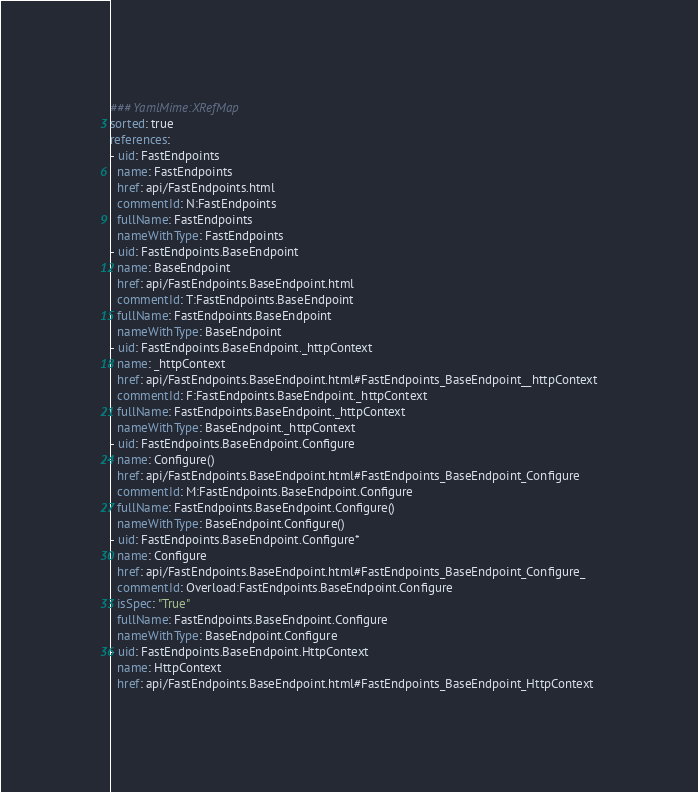<code> <loc_0><loc_0><loc_500><loc_500><_YAML_>### YamlMime:XRefMap
sorted: true
references:
- uid: FastEndpoints
  name: FastEndpoints
  href: api/FastEndpoints.html
  commentId: N:FastEndpoints
  fullName: FastEndpoints
  nameWithType: FastEndpoints
- uid: FastEndpoints.BaseEndpoint
  name: BaseEndpoint
  href: api/FastEndpoints.BaseEndpoint.html
  commentId: T:FastEndpoints.BaseEndpoint
  fullName: FastEndpoints.BaseEndpoint
  nameWithType: BaseEndpoint
- uid: FastEndpoints.BaseEndpoint._httpContext
  name: _httpContext
  href: api/FastEndpoints.BaseEndpoint.html#FastEndpoints_BaseEndpoint__httpContext
  commentId: F:FastEndpoints.BaseEndpoint._httpContext
  fullName: FastEndpoints.BaseEndpoint._httpContext
  nameWithType: BaseEndpoint._httpContext
- uid: FastEndpoints.BaseEndpoint.Configure
  name: Configure()
  href: api/FastEndpoints.BaseEndpoint.html#FastEndpoints_BaseEndpoint_Configure
  commentId: M:FastEndpoints.BaseEndpoint.Configure
  fullName: FastEndpoints.BaseEndpoint.Configure()
  nameWithType: BaseEndpoint.Configure()
- uid: FastEndpoints.BaseEndpoint.Configure*
  name: Configure
  href: api/FastEndpoints.BaseEndpoint.html#FastEndpoints_BaseEndpoint_Configure_
  commentId: Overload:FastEndpoints.BaseEndpoint.Configure
  isSpec: "True"
  fullName: FastEndpoints.BaseEndpoint.Configure
  nameWithType: BaseEndpoint.Configure
- uid: FastEndpoints.BaseEndpoint.HttpContext
  name: HttpContext
  href: api/FastEndpoints.BaseEndpoint.html#FastEndpoints_BaseEndpoint_HttpContext</code> 